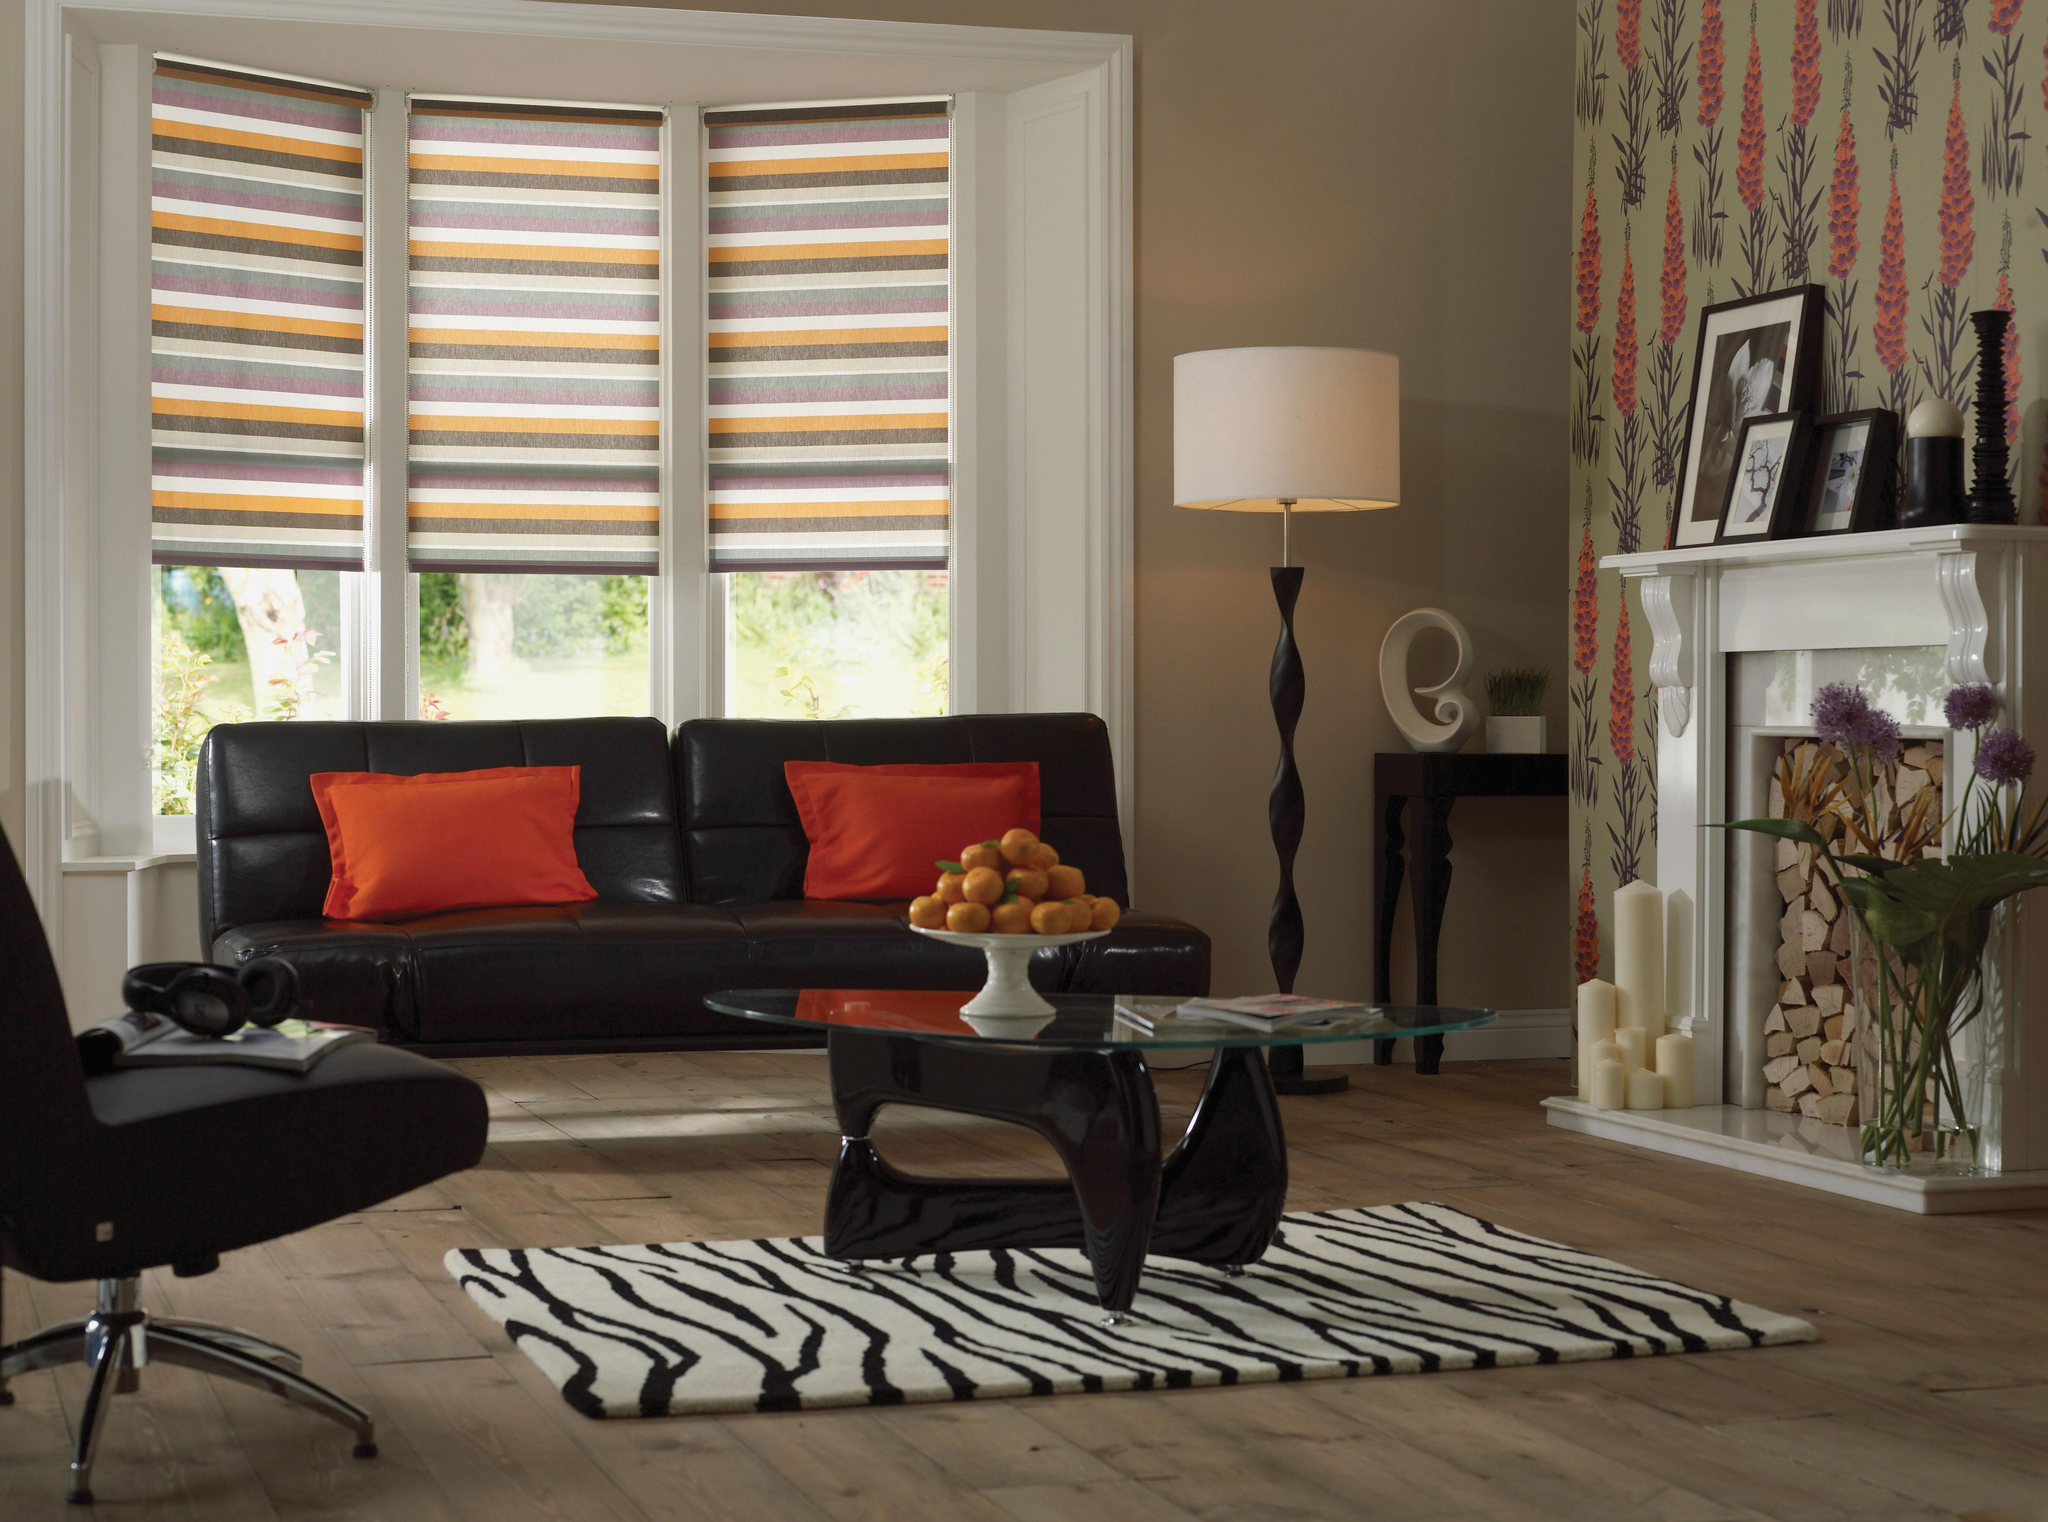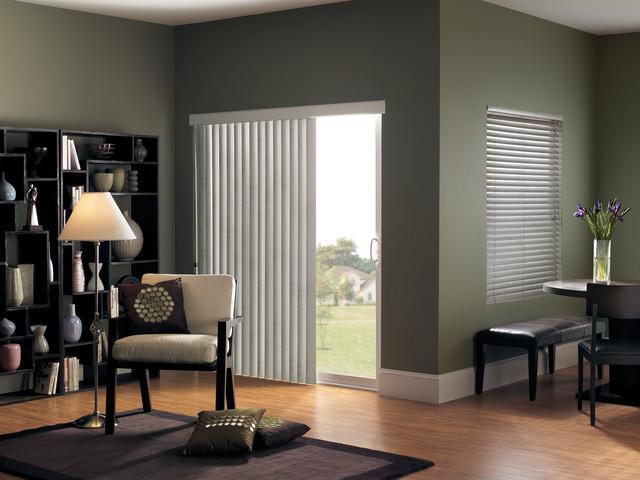The first image is the image on the left, the second image is the image on the right. Analyze the images presented: Is the assertion "There are exactly five shades." valid? Answer yes or no. Yes. The first image is the image on the left, the second image is the image on the right. Considering the images on both sides, is "There are five blinds." valid? Answer yes or no. Yes. 